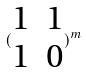Convert formula to latex. <formula><loc_0><loc_0><loc_500><loc_500>( \begin{matrix} 1 & 1 \\ 1 & 0 \end{matrix} ) ^ { m }</formula> 